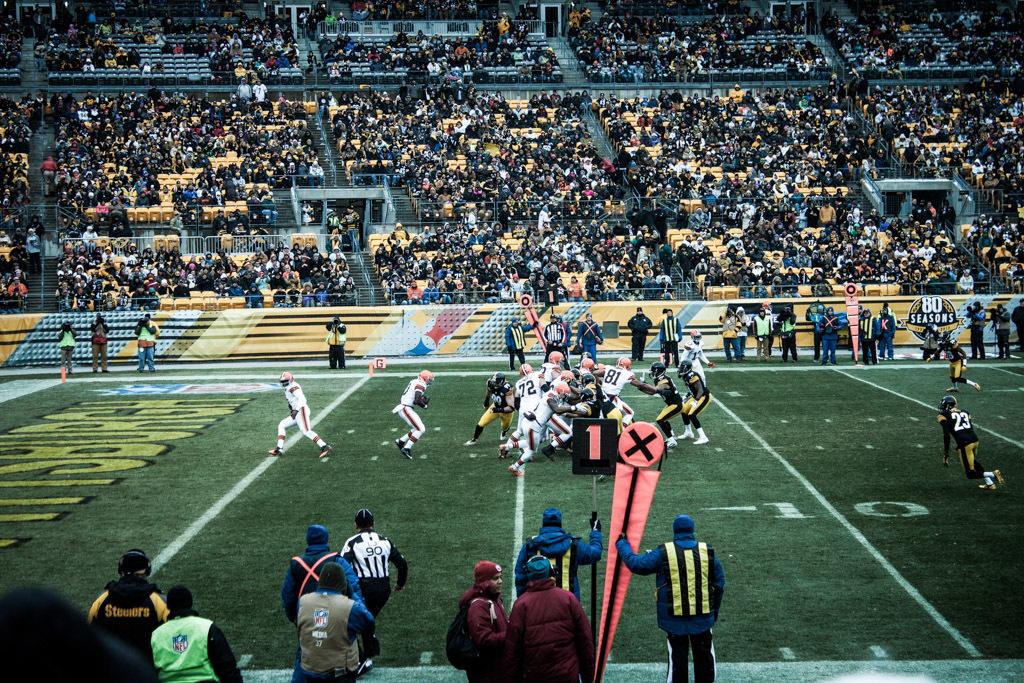What company is in the photo?
Offer a very short reply. Nfl. How many seasons, according to the banner on the far side of the field?
Your response must be concise. 80. 